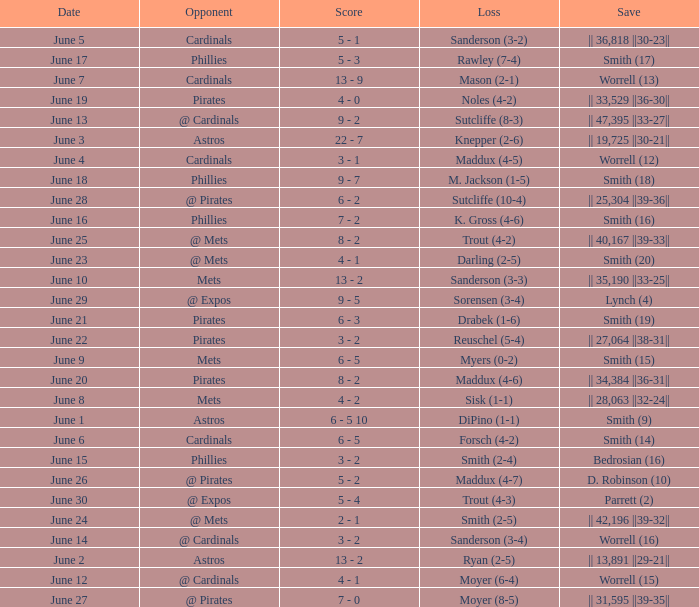The game with a loss of smith (2-4) ended with what score? 3 - 2. 